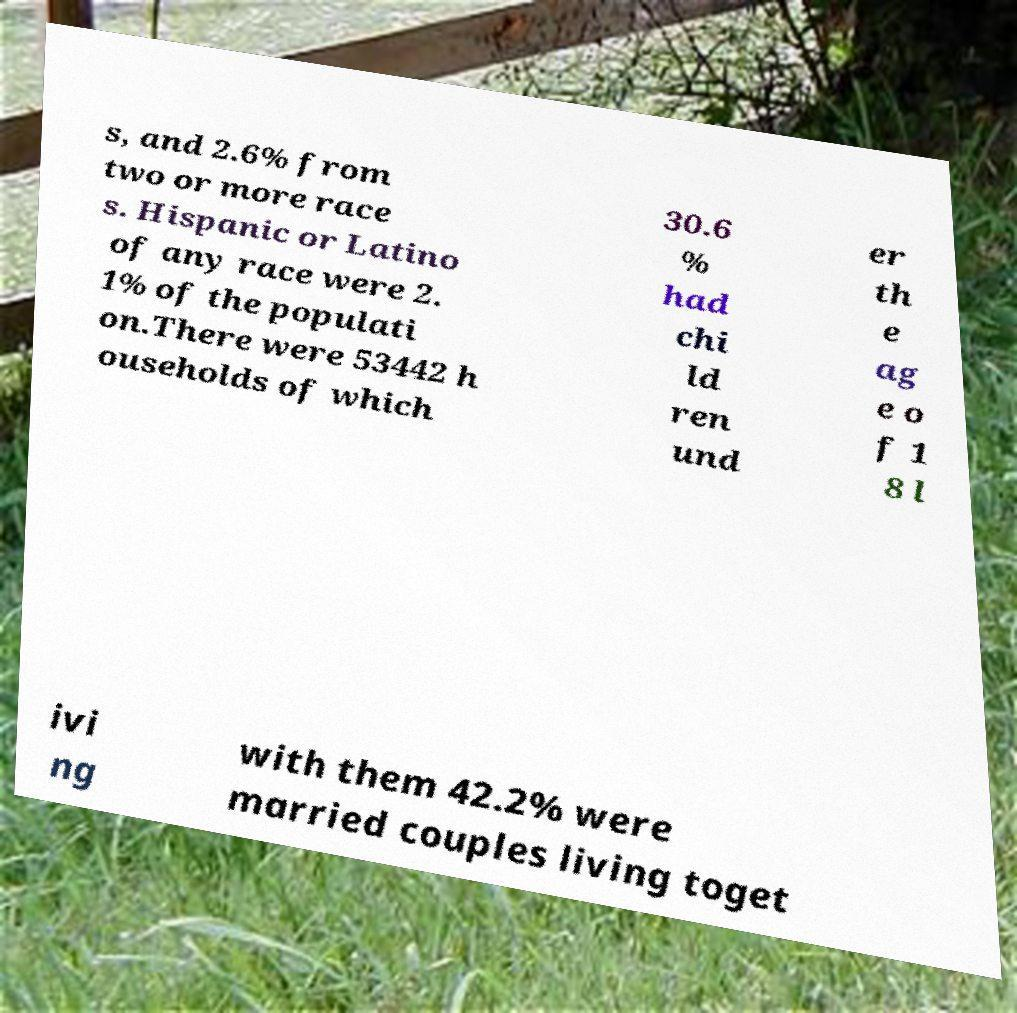What messages or text are displayed in this image? I need them in a readable, typed format. s, and 2.6% from two or more race s. Hispanic or Latino of any race were 2. 1% of the populati on.There were 53442 h ouseholds of which 30.6 % had chi ld ren und er th e ag e o f 1 8 l ivi ng with them 42.2% were married couples living toget 